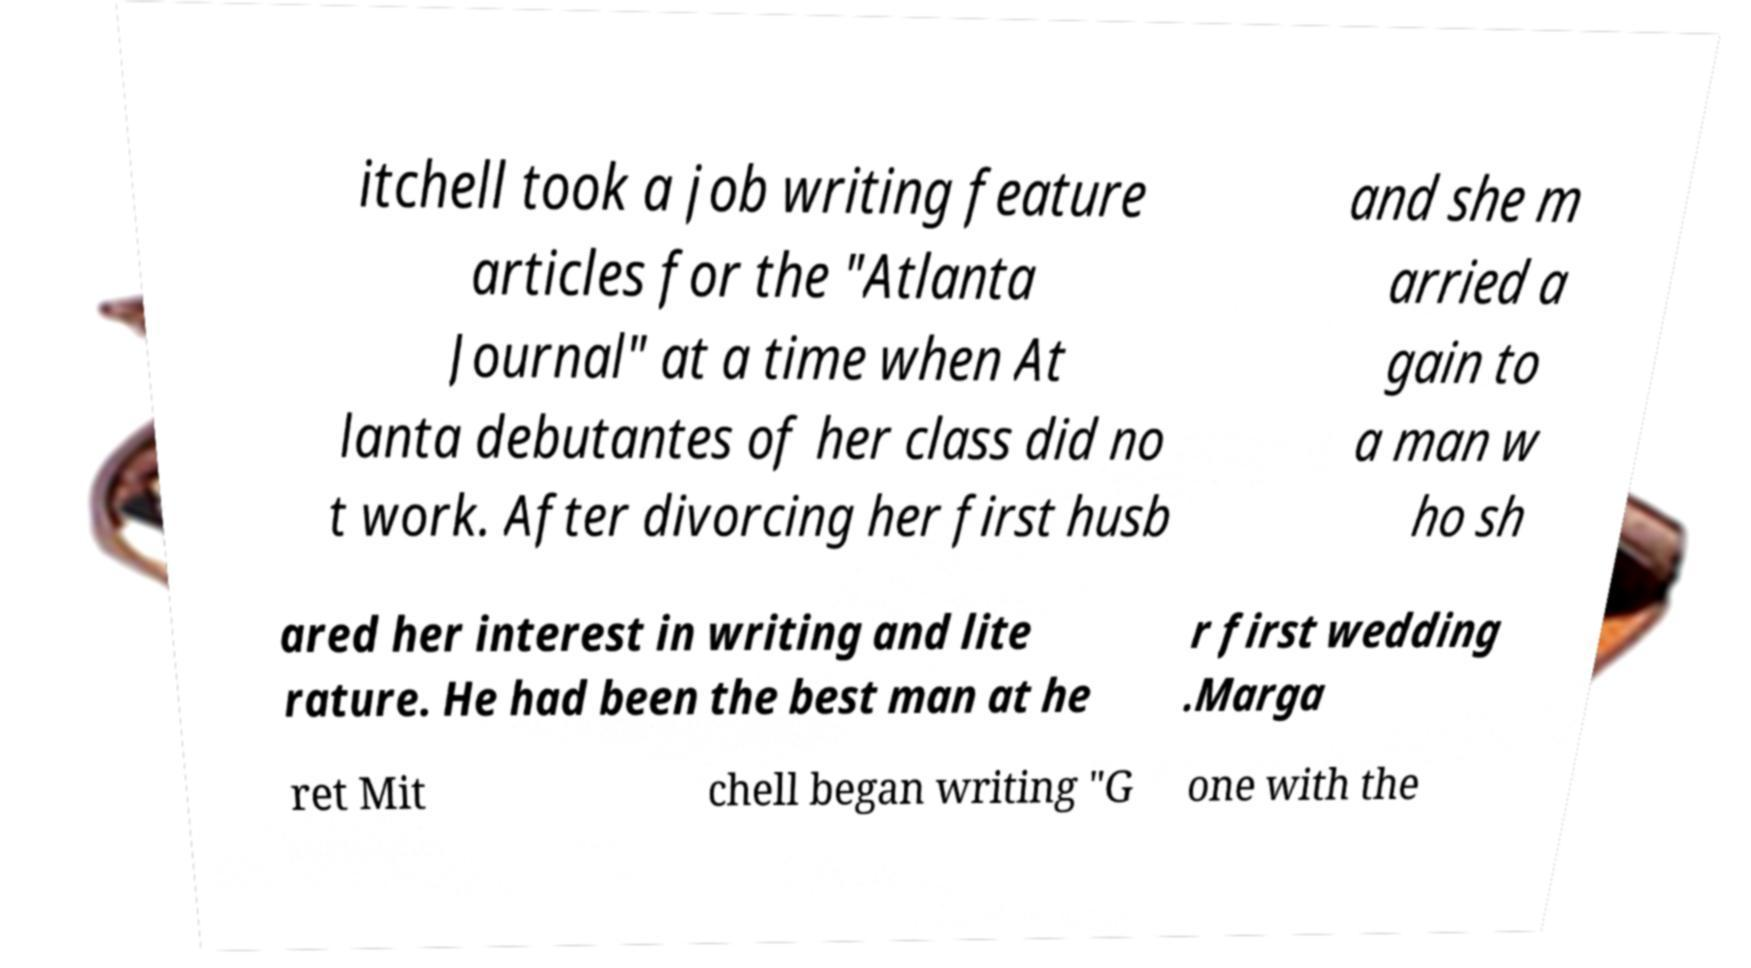For documentation purposes, I need the text within this image transcribed. Could you provide that? itchell took a job writing feature articles for the "Atlanta Journal" at a time when At lanta debutantes of her class did no t work. After divorcing her first husb and she m arried a gain to a man w ho sh ared her interest in writing and lite rature. He had been the best man at he r first wedding .Marga ret Mit chell began writing "G one with the 